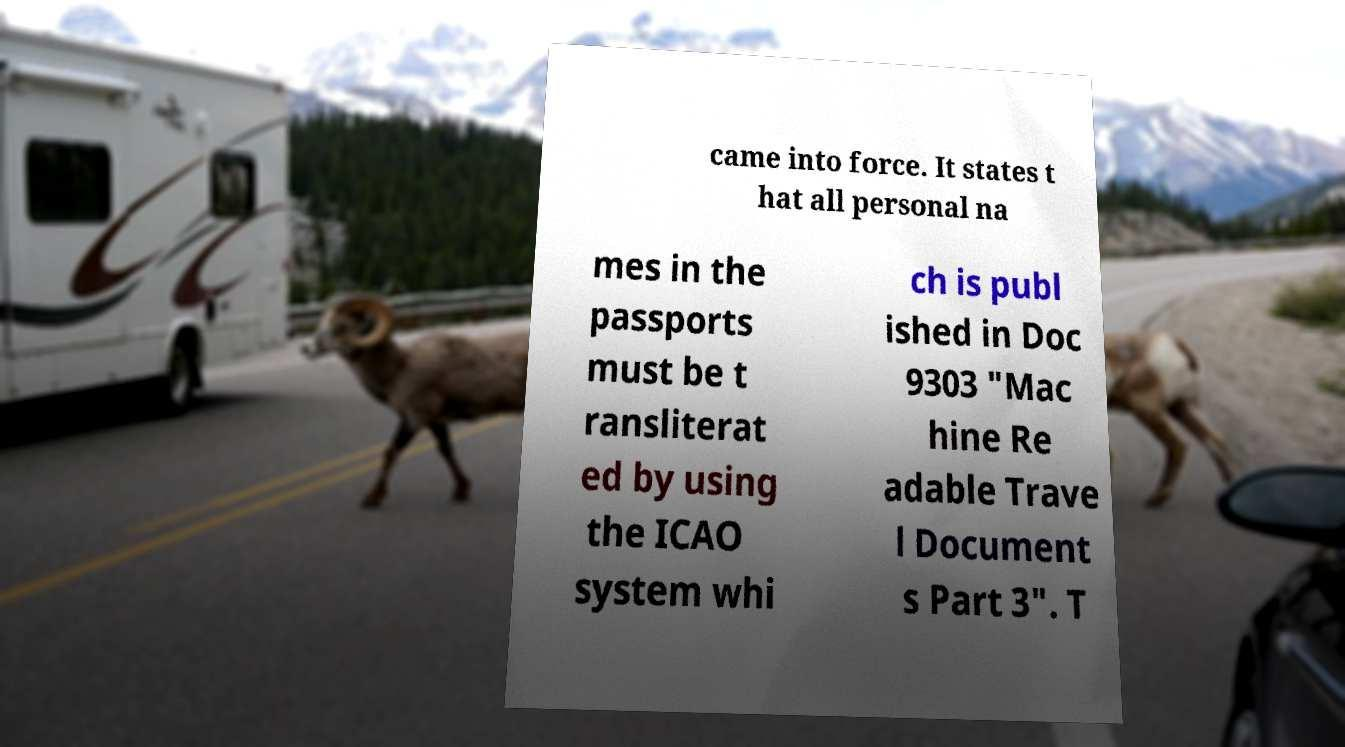I need the written content from this picture converted into text. Can you do that? came into force. It states t hat all personal na mes in the passports must be t ransliterat ed by using the ICAO system whi ch is publ ished in Doc 9303 "Mac hine Re adable Trave l Document s Part 3". T 